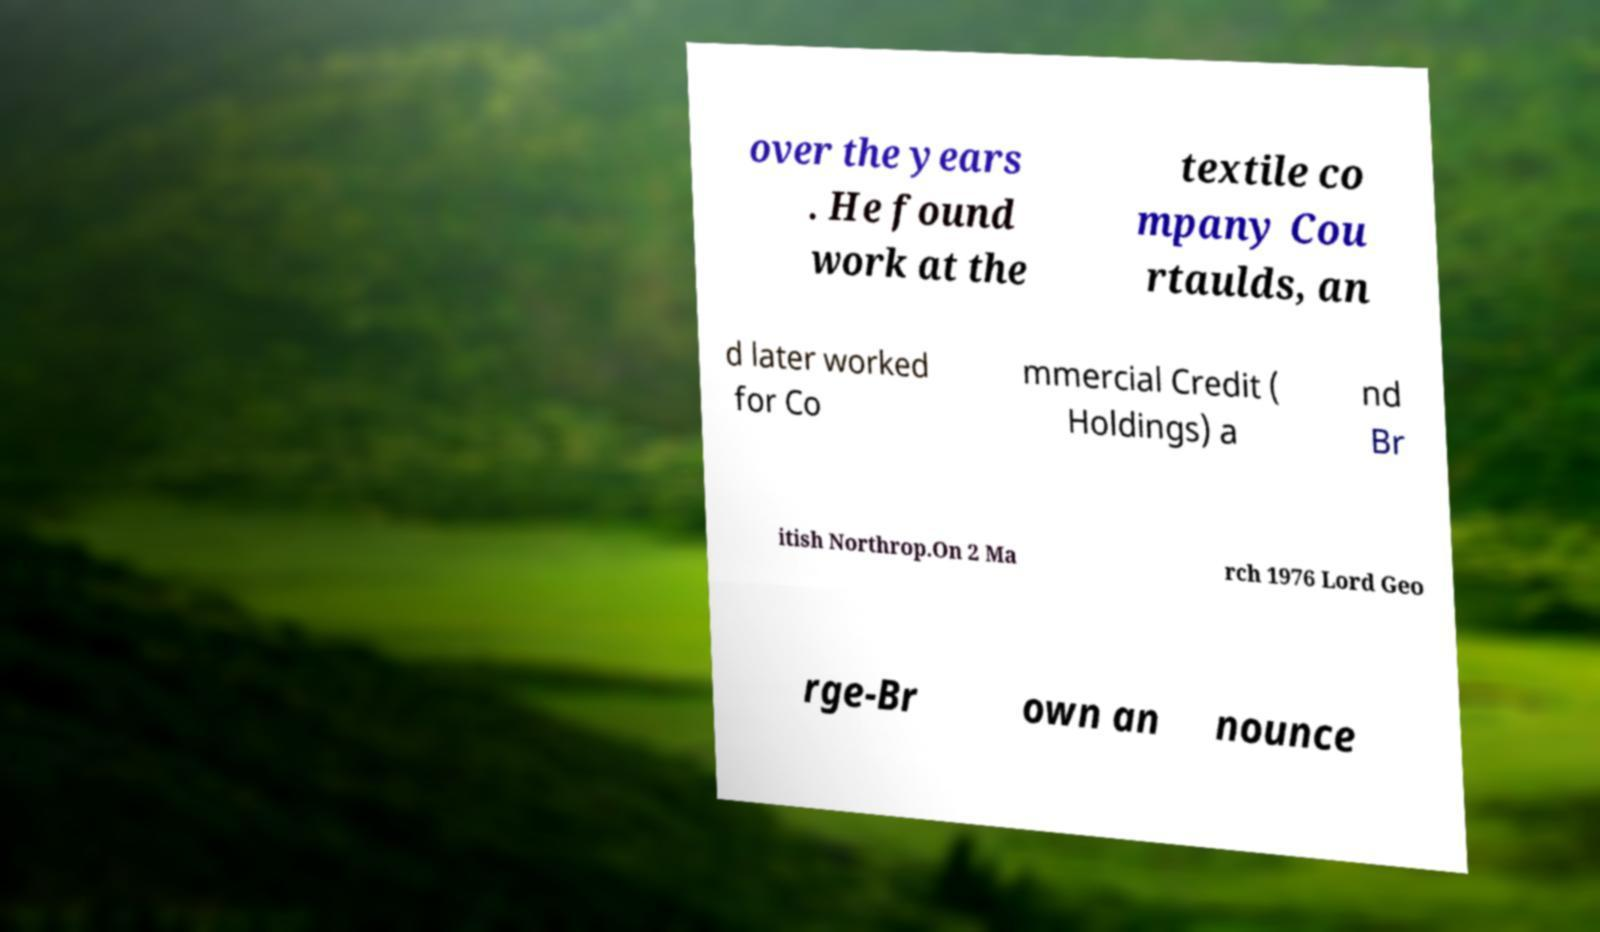There's text embedded in this image that I need extracted. Can you transcribe it verbatim? over the years . He found work at the textile co mpany Cou rtaulds, an d later worked for Co mmercial Credit ( Holdings) a nd Br itish Northrop.On 2 Ma rch 1976 Lord Geo rge-Br own an nounce 